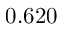<formula> <loc_0><loc_0><loc_500><loc_500>0 . 6 2 0</formula> 